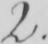Transcribe the text shown in this historical manuscript line. 2 . 